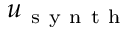<formula> <loc_0><loc_0><loc_500><loc_500>u _ { s y n t h }</formula> 